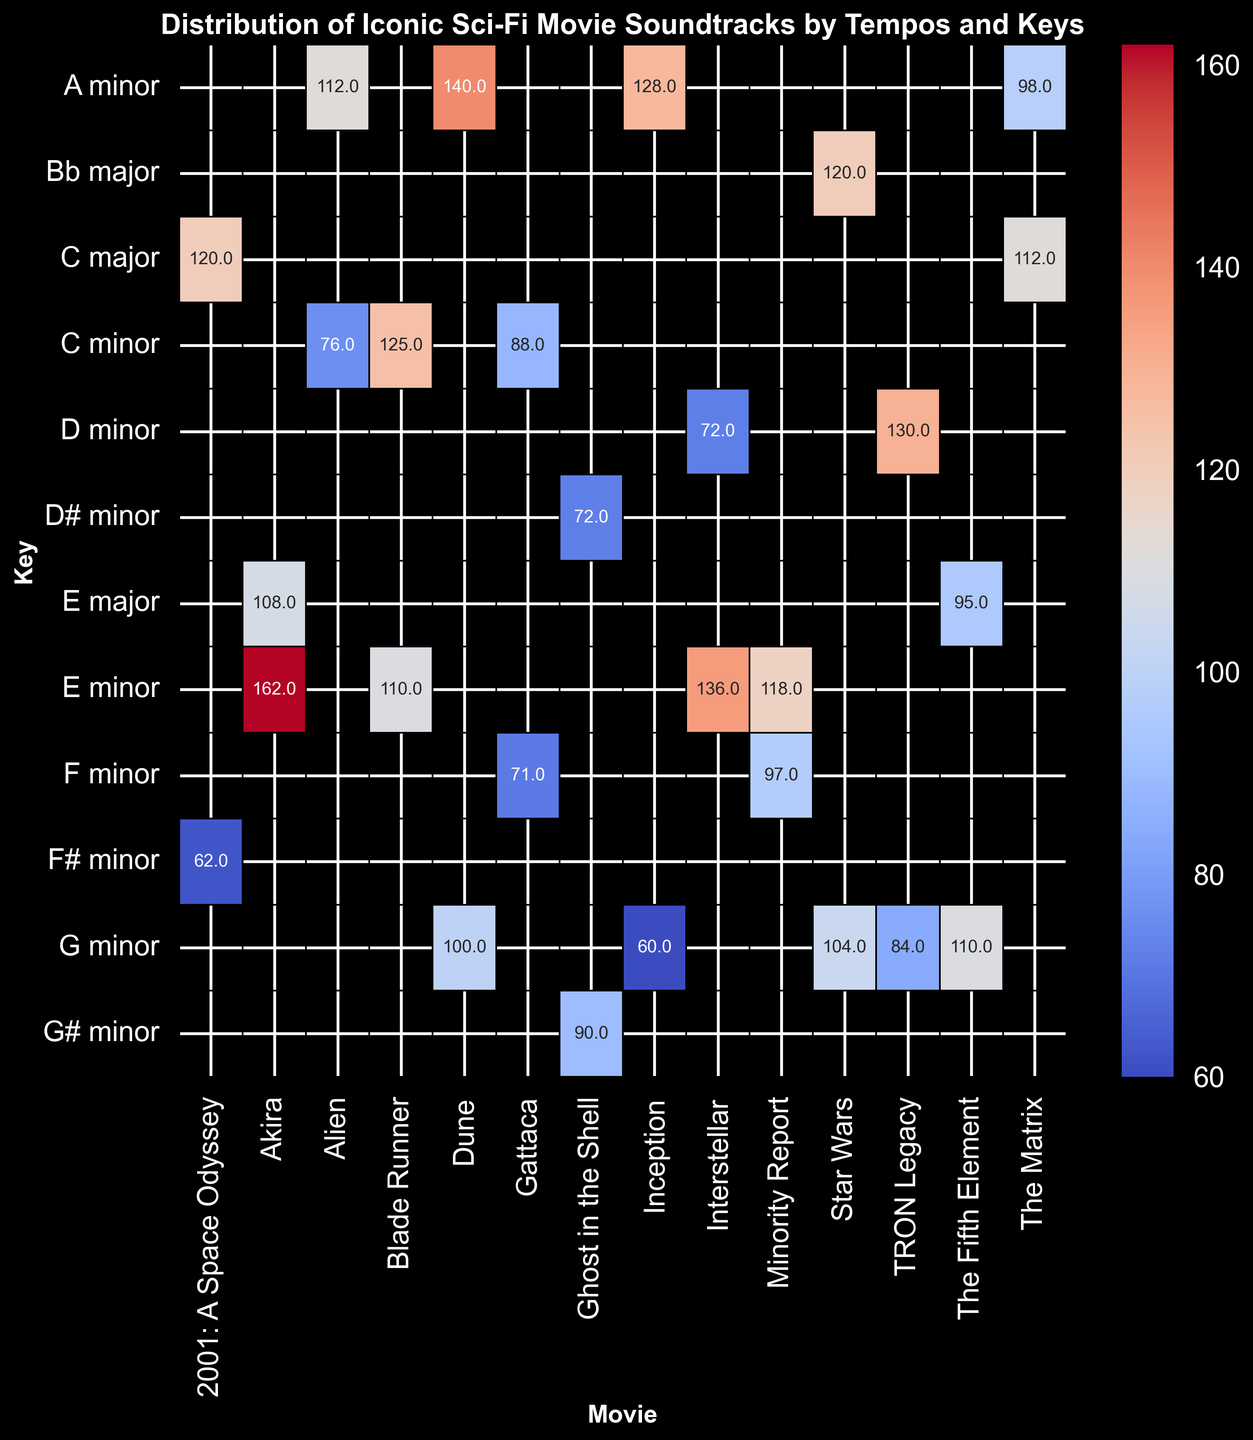What's the average tempo of soundtracks in E minor? To find the average tempo of soundtracks in E minor, locate the E minor row in the heatmap and sum the visible values: 110 (Blade Runner Main Titles), 118 (Minority Report The Greenhouse Effect), 84 (Ghost in the Shell Uta I - Making of Cyborg), 125 (Blade Runner End Titles). Then divide by the number of soundtracks: (110 + 118 + 84 + 125) / 4 = 109.3
Answer: 109.3 BPM Which movie has the highest average tempo? Find the column with the highest average values, taking into account all values shown. Sum the tempo values for each movie and divide by the number of soundtracks listed. The movie with the highest average tempo is Dune with values of 100 and 140 BPM: (100 + 140) / 2 = 120 BPM.
Answer: Dune Which key has the most variation in tempos? For each key, assess the range (difference between the maximum and minimum values). For example, E minor has tempos ranging from 84 to 162 BPM, which gives a variation range of 78 BPM. Compare it to other keys to determine that E minor has the largest tempo variation.
Answer: E minor Which movie has the most diverse range of keys used? Identify the movies by observing the number of unique key entries in each column. For instance, Star Wars with Bb major and G minor involves two keys, while Interstellar shows D minor and G minor. However, The Matrix includes A minor and C major. Verify the diversity of keys used by comparing the unique key counts for each movie. The Matrix features two different keys from the dataset.
Answer: The Matrix Which soundtrack has the lowest tempo? Look for the smallest tempo value in the heatmap. The lowest tempo is 60 BPM for the soundtrack "Time" from the movie Inception.
Answer: Inception's Time Which two movies share the same key and have the closest tempo values? Compare the tempos of soundtracks in identical keys. G Minor is shared between TRON Legacy with “The Grid” at 84 BPM and Star Wars with “Imperial March” at 104 BPM. The tempo difference is 20 BPM. Other comparisons show larger differences, so TRON Legacy and Star Wars have the closest tempo values in a shared key.
Answer: TRON Legacy and Star Wars How does the distribution of tempos compare between Inception and Interstellar? Compare the entries in the Inception and Interstellar columns. Inception has tempos of 60 and 128 BPM, which shows a wide range. Interstellar displays tempos of 72 and 136 BPM. Both movies demonstrate a contrast in tempos, but Inception's range of 60 to 128 BPM spans less than Interstellar’s 72 to 136 BPM.
Answer: Both show wide tempo ranges, with Interstellar having a broader range What is the difference in average tempo between Akira and Minority Report? Calculate the average tempos for each movie. Akira's values of 108 and 162 BPM give an average of (108 + 162) / 2 = 135 BPM. Minority Report’s tempos are 97 and 118 BPM, giving (97 + 118) / 2 = 107.5 BPM. Subtracting these averages provides: 135 - 107.5 = 27.5 BPM.
Answer: 27.5 BPM Which soundtrack in the key of A minor has the highest tempo? Examine the A minor row to find the highest tempo value. Options include 98 (The Matrix Clubbed to Death), 128 (Inception Mombasa), and 140 (Dune Paul's Dream). The highest tempo in A minor is 140 BPM from Dune Paul's Dream.
Answer: Dune's Paul's Dream 